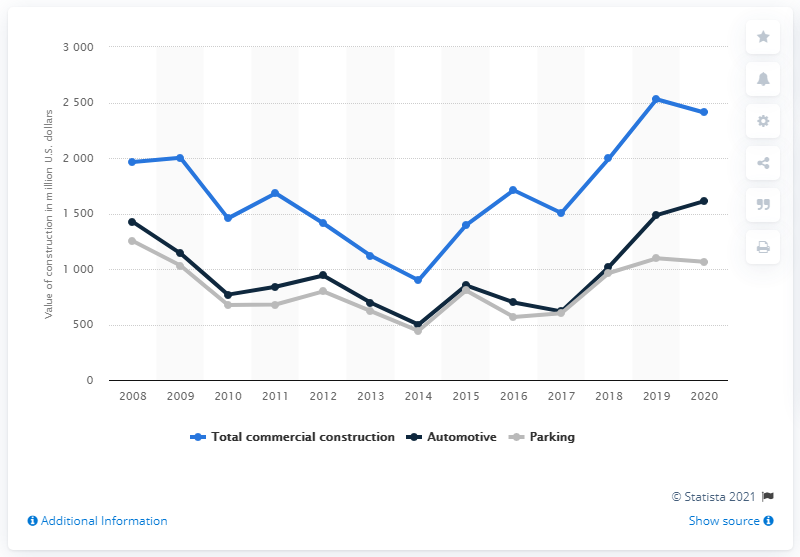Specify some key components in this picture. In the year 2020, the value of commercial construction in the United States was 2410. 